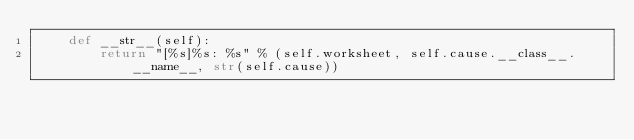<code> <loc_0><loc_0><loc_500><loc_500><_Python_>    def __str__(self):
        return "[%s]%s: %s" % (self.worksheet, self.cause.__class__.__name__, str(self.cause))

</code> 